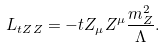<formula> <loc_0><loc_0><loc_500><loc_500>L _ { t Z Z } = - t Z _ { \mu } Z ^ { \mu } \frac { m _ { Z } ^ { 2 } } { \Lambda } .</formula> 